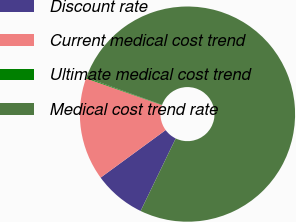Convert chart. <chart><loc_0><loc_0><loc_500><loc_500><pie_chart><fcel>Discount rate<fcel>Current medical cost trend<fcel>Ultimate medical cost trend<fcel>Medical cost trend rate<nl><fcel>7.78%<fcel>15.44%<fcel>0.13%<fcel>76.65%<nl></chart> 